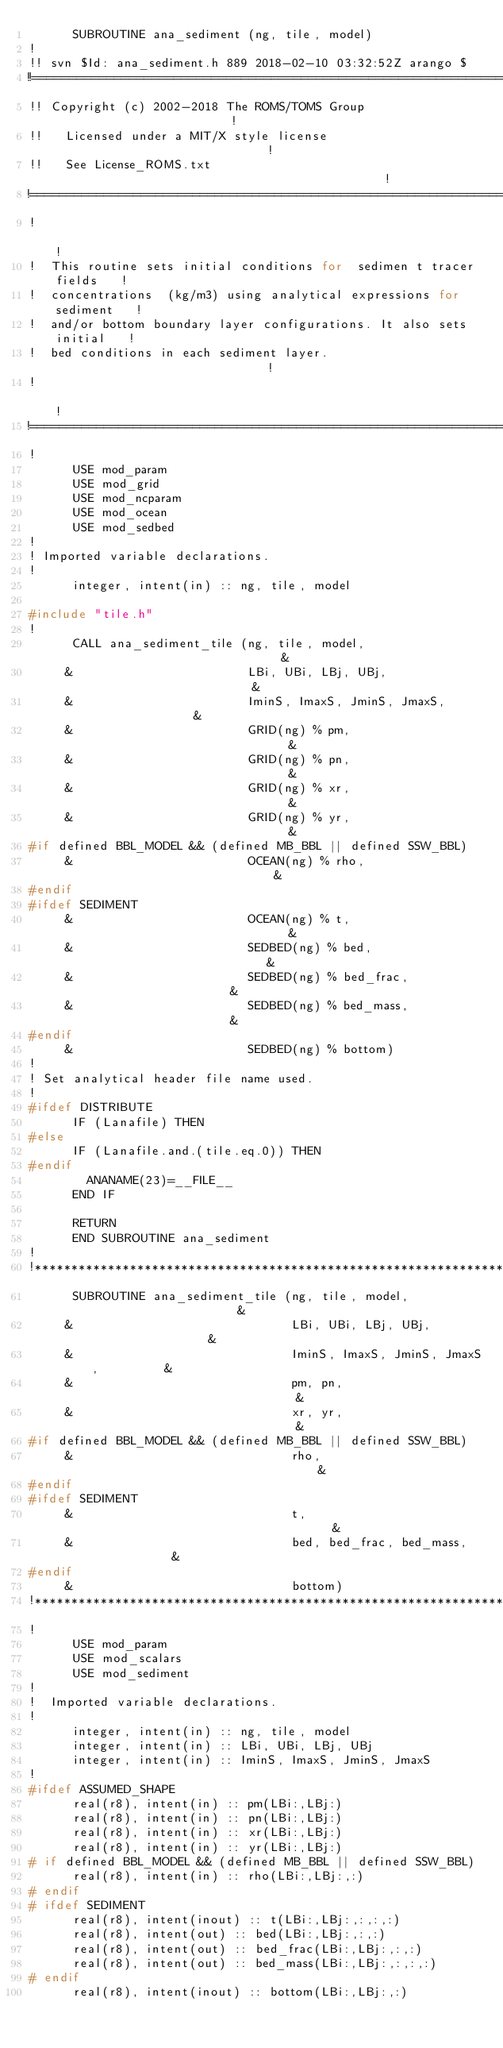<code> <loc_0><loc_0><loc_500><loc_500><_C_>      SUBROUTINE ana_sediment (ng, tile, model)
!
!! svn $Id: ana_sediment.h 889 2018-02-10 03:32:52Z arango $
!!======================================================================
!! Copyright (c) 2002-2018 The ROMS/TOMS Group                         !
!!   Licensed under a MIT/X style license                              !
!!   See License_ROMS.txt                                              !
!=======================================================================
!                                                                      !
!  This routine sets initial conditions for  sedimen t tracer fields   !
!  concentrations  (kg/m3) using analytical expressions for sediment   !
!  and/or bottom boundary layer configurations. It also sets initial   !
!  bed conditions in each sediment layer.                              !
!                                                                      !
!=======================================================================
!
      USE mod_param
      USE mod_grid
      USE mod_ncparam
      USE mod_ocean
      USE mod_sedbed
!
! Imported variable declarations.
!
      integer, intent(in) :: ng, tile, model

#include "tile.h"
!
      CALL ana_sediment_tile (ng, tile, model,                          &
     &                        LBi, UBi, LBj, UBj,                       &
     &                        IminS, ImaxS, JminS, JmaxS,               &
     &                        GRID(ng) % pm,                            &
     &                        GRID(ng) % pn,                            &
     &                        GRID(ng) % xr,                            &
     &                        GRID(ng) % yr,                            &
#if defined BBL_MODEL && (defined MB_BBL || defined SSW_BBL)
     &                        OCEAN(ng) % rho,                          &
#endif
#ifdef SEDIMENT
     &                        OCEAN(ng) % t,                            &
     &                        SEDBED(ng) % bed,                         &
     &                        SEDBED(ng) % bed_frac,                    &
     &                        SEDBED(ng) % bed_mass,                    &
#endif
     &                        SEDBED(ng) % bottom)
!
! Set analytical header file name used.
!
#ifdef DISTRIBUTE
      IF (Lanafile) THEN
#else
      IF (Lanafile.and.(tile.eq.0)) THEN
#endif
        ANANAME(23)=__FILE__
      END IF

      RETURN
      END SUBROUTINE ana_sediment
!
!***********************************************************************
      SUBROUTINE ana_sediment_tile (ng, tile, model,                    &
     &                              LBi, UBi, LBj, UBj,                 &
     &                              IminS, ImaxS, JminS, JmaxS,         &
     &                              pm, pn,                             &
     &                              xr, yr,                             &
#if defined BBL_MODEL && (defined MB_BBL || defined SSW_BBL)
     &                              rho,                                &
#endif
#ifdef SEDIMENT
     &                              t,                                  &
     &                              bed, bed_frac, bed_mass,            &
#endif
     &                              bottom)
!***********************************************************************
!
      USE mod_param
      USE mod_scalars
      USE mod_sediment
!
!  Imported variable declarations.
!
      integer, intent(in) :: ng, tile, model
      integer, intent(in) :: LBi, UBi, LBj, UBj
      integer, intent(in) :: IminS, ImaxS, JminS, JmaxS
!
#ifdef ASSUMED_SHAPE
      real(r8), intent(in) :: pm(LBi:,LBj:)
      real(r8), intent(in) :: pn(LBi:,LBj:)
      real(r8), intent(in) :: xr(LBi:,LBj:)
      real(r8), intent(in) :: yr(LBi:,LBj:)
# if defined BBL_MODEL && (defined MB_BBL || defined SSW_BBL)
      real(r8), intent(in) :: rho(LBi:,LBj:,:)
# endif
# ifdef SEDIMENT
      real(r8), intent(inout) :: t(LBi:,LBj:,:,:,:)
      real(r8), intent(out) :: bed(LBi:,LBj:,:,:)
      real(r8), intent(out) :: bed_frac(LBi:,LBj:,:,:)
      real(r8), intent(out) :: bed_mass(LBi:,LBj:,:,:,:)
# endif
      real(r8), intent(inout) :: bottom(LBi:,LBj:,:)</code> 